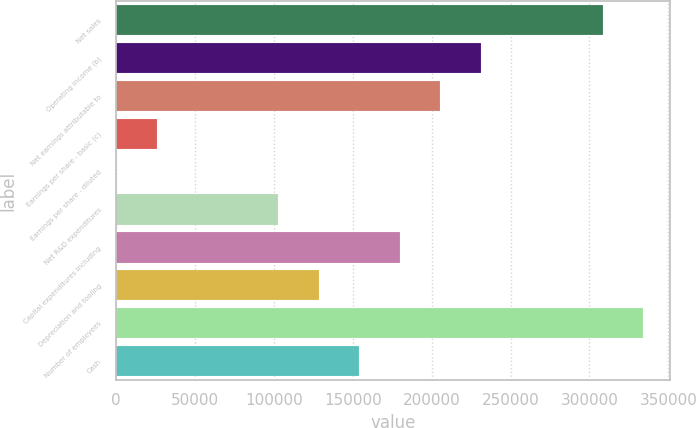Convert chart to OTSL. <chart><loc_0><loc_0><loc_500><loc_500><bar_chart><fcel>Net sales<fcel>Operating income (b)<fcel>Net earnings attributable to<fcel>Earnings per share - basic (c)<fcel>Earnings per share - diluted<fcel>Net R&D expenditures<fcel>Capital expenditures including<fcel>Depreciation and tooling<fcel>Number of employees<fcel>Cash<nl><fcel>308323<fcel>231243<fcel>205549<fcel>25695.6<fcel>2.22<fcel>102776<fcel>179856<fcel>128469<fcel>334016<fcel>154162<nl></chart> 